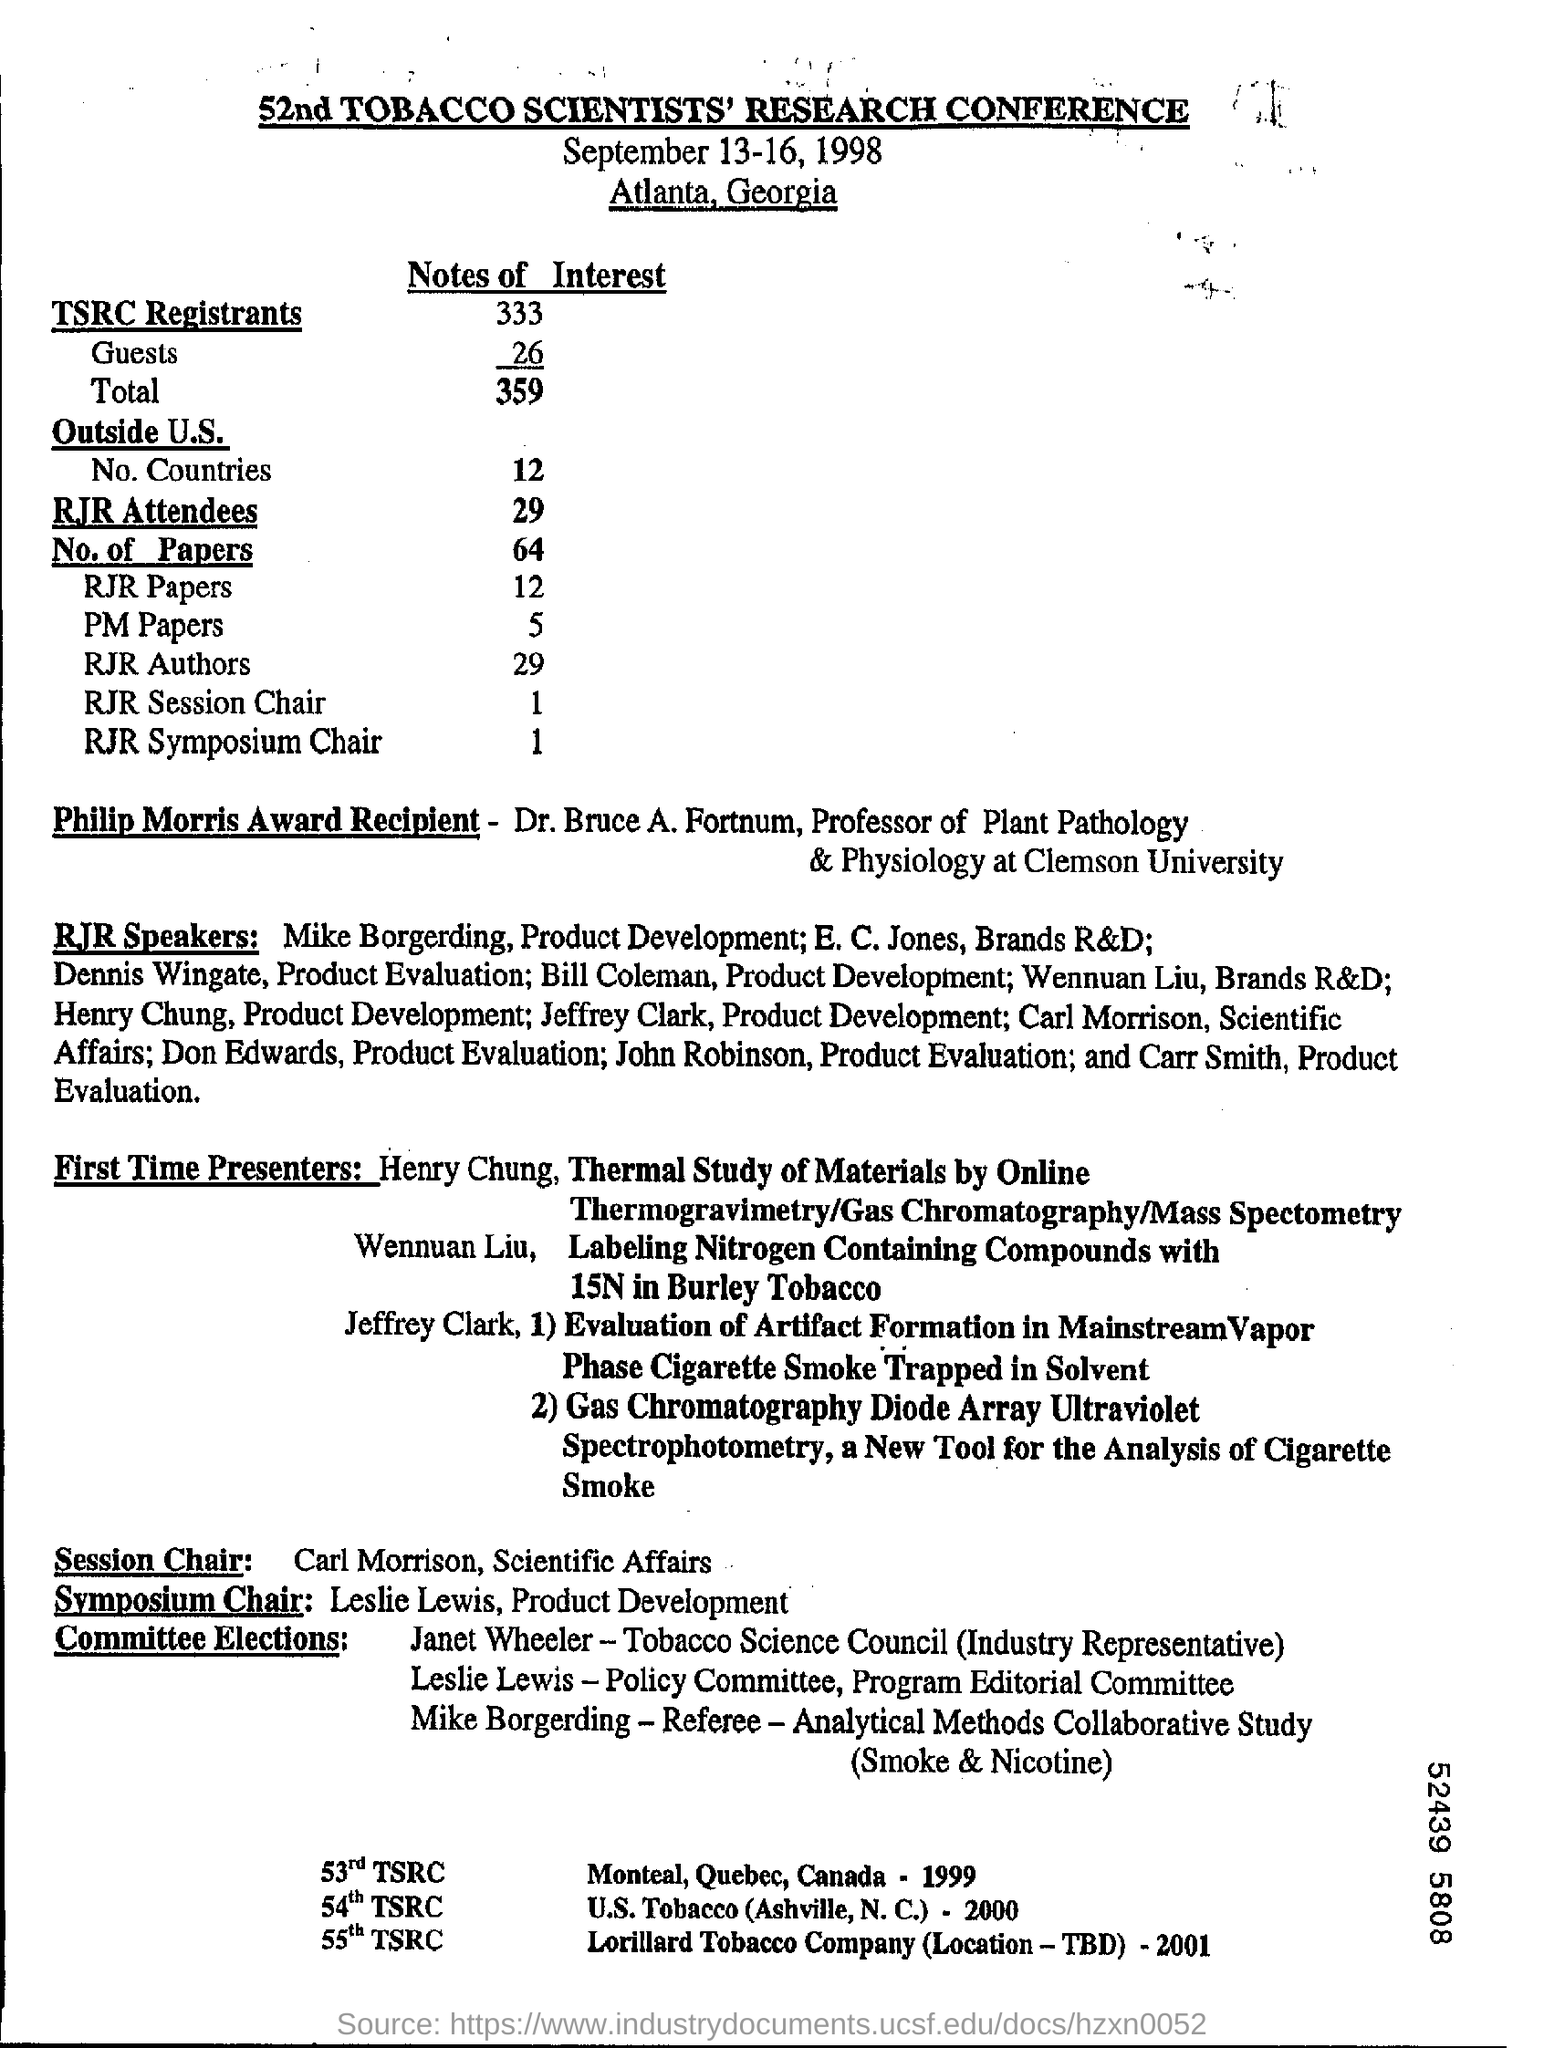Highlight a few significant elements in this photo. The conference was held in Atlanta, Georgia. There were 29 attendees at the RJR conference. Total number of TSRC registrants is 359. The TSRC is the Total Worker Replacement Concept, which is a measure of the proportion of the workforce that is made up of full-time equivalent (FTE) workers who are not direct employees of the organization. 